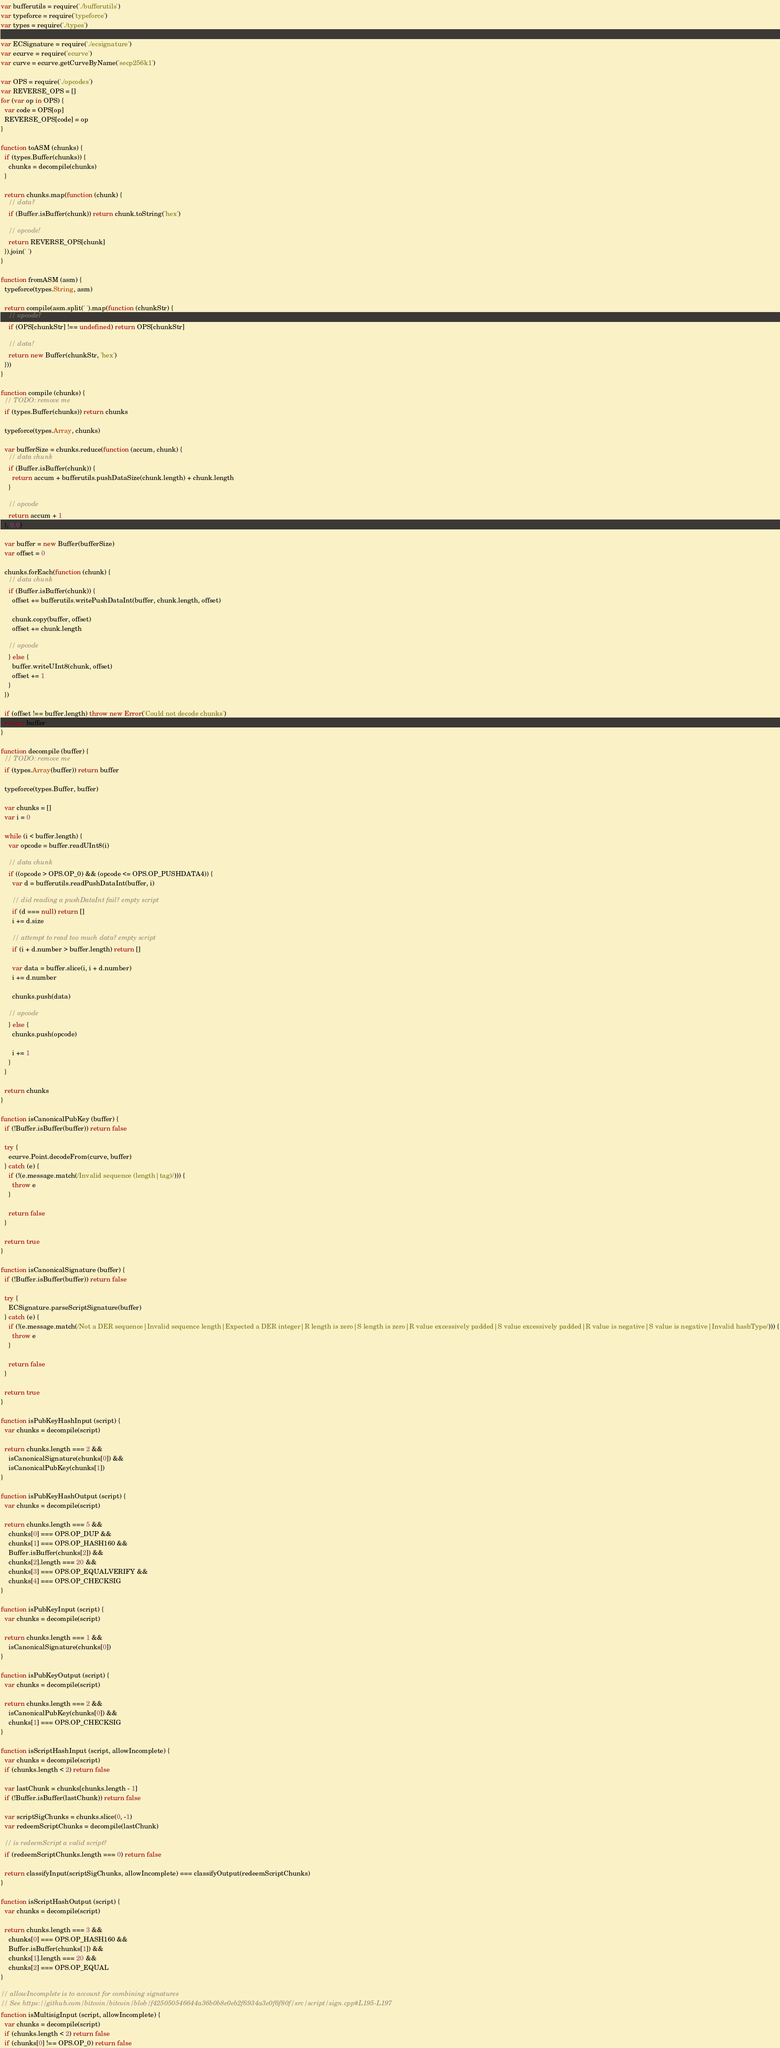Convert code to text. <code><loc_0><loc_0><loc_500><loc_500><_JavaScript_>var bufferutils = require('./bufferutils')
var typeforce = require('typeforce')
var types = require('./types')

var ECSignature = require('./ecsignature')
var ecurve = require('ecurve')
var curve = ecurve.getCurveByName('secp256k1')

var OPS = require('./opcodes')
var REVERSE_OPS = []
for (var op in OPS) {
  var code = OPS[op]
  REVERSE_OPS[code] = op
}

function toASM (chunks) {
  if (types.Buffer(chunks)) {
    chunks = decompile(chunks)
  }

  return chunks.map(function (chunk) {
    // data?
    if (Buffer.isBuffer(chunk)) return chunk.toString('hex')

    // opcode!
    return REVERSE_OPS[chunk]
  }).join(' ')
}

function fromASM (asm) {
  typeforce(types.String, asm)

  return compile(asm.split(' ').map(function (chunkStr) {
    // opcode?
    if (OPS[chunkStr] !== undefined) return OPS[chunkStr]

    // data!
    return new Buffer(chunkStr, 'hex')
  }))
}

function compile (chunks) {
  // TODO: remove me
  if (types.Buffer(chunks)) return chunks

  typeforce(types.Array, chunks)

  var bufferSize = chunks.reduce(function (accum, chunk) {
    // data chunk
    if (Buffer.isBuffer(chunk)) {
      return accum + bufferutils.pushDataSize(chunk.length) + chunk.length
    }

    // opcode
    return accum + 1
  }, 0.0)

  var buffer = new Buffer(bufferSize)
  var offset = 0

  chunks.forEach(function (chunk) {
    // data chunk
    if (Buffer.isBuffer(chunk)) {
      offset += bufferutils.writePushDataInt(buffer, chunk.length, offset)

      chunk.copy(buffer, offset)
      offset += chunk.length

    // opcode
    } else {
      buffer.writeUInt8(chunk, offset)
      offset += 1
    }
  })

  if (offset !== buffer.length) throw new Error('Could not decode chunks')
  return buffer
}

function decompile (buffer) {
  // TODO: remove me
  if (types.Array(buffer)) return buffer

  typeforce(types.Buffer, buffer)

  var chunks = []
  var i = 0

  while (i < buffer.length) {
    var opcode = buffer.readUInt8(i)

    // data chunk
    if ((opcode > OPS.OP_0) && (opcode <= OPS.OP_PUSHDATA4)) {
      var d = bufferutils.readPushDataInt(buffer, i)

      // did reading a pushDataInt fail? empty script
      if (d === null) return []
      i += d.size

      // attempt to read too much data? empty script
      if (i + d.number > buffer.length) return []

      var data = buffer.slice(i, i + d.number)
      i += d.number

      chunks.push(data)

    // opcode
    } else {
      chunks.push(opcode)

      i += 1
    }
  }

  return chunks
}

function isCanonicalPubKey (buffer) {
  if (!Buffer.isBuffer(buffer)) return false

  try {
    ecurve.Point.decodeFrom(curve, buffer)
  } catch (e) {
    if (!(e.message.match(/Invalid sequence (length|tag)/))) {
      throw e
    }

    return false
  }

  return true
}

function isCanonicalSignature (buffer) {
  if (!Buffer.isBuffer(buffer)) return false

  try {
    ECSignature.parseScriptSignature(buffer)
  } catch (e) {
    if (!(e.message.match(/Not a DER sequence|Invalid sequence length|Expected a DER integer|R length is zero|S length is zero|R value excessively padded|S value excessively padded|R value is negative|S value is negative|Invalid hashType/))) {
      throw e
    }

    return false
  }

  return true
}

function isPubKeyHashInput (script) {
  var chunks = decompile(script)

  return chunks.length === 2 &&
    isCanonicalSignature(chunks[0]) &&
    isCanonicalPubKey(chunks[1])
}

function isPubKeyHashOutput (script) {
  var chunks = decompile(script)

  return chunks.length === 5 &&
    chunks[0] === OPS.OP_DUP &&
    chunks[1] === OPS.OP_HASH160 &&
    Buffer.isBuffer(chunks[2]) &&
    chunks[2].length === 20 &&
    chunks[3] === OPS.OP_EQUALVERIFY &&
    chunks[4] === OPS.OP_CHECKSIG
}

function isPubKeyInput (script) {
  var chunks = decompile(script)

  return chunks.length === 1 &&
    isCanonicalSignature(chunks[0])
}

function isPubKeyOutput (script) {
  var chunks = decompile(script)

  return chunks.length === 2 &&
    isCanonicalPubKey(chunks[0]) &&
    chunks[1] === OPS.OP_CHECKSIG
}

function isScriptHashInput (script, allowIncomplete) {
  var chunks = decompile(script)
  if (chunks.length < 2) return false

  var lastChunk = chunks[chunks.length - 1]
  if (!Buffer.isBuffer(lastChunk)) return false

  var scriptSigChunks = chunks.slice(0, -1)
  var redeemScriptChunks = decompile(lastChunk)

  // is redeemScript a valid script?
  if (redeemScriptChunks.length === 0) return false

  return classifyInput(scriptSigChunks, allowIncomplete) === classifyOutput(redeemScriptChunks)
}

function isScriptHashOutput (script) {
  var chunks = decompile(script)

  return chunks.length === 3 &&
    chunks[0] === OPS.OP_HASH160 &&
    Buffer.isBuffer(chunks[1]) &&
    chunks[1].length === 20 &&
    chunks[2] === OPS.OP_EQUAL
}

// allowIncomplete is to account for combining signatures
// See https://github.com/bitcoin/bitcoin/blob/f425050546644a36b0b8e0eb2f6934a3e0f6f80f/src/script/sign.cpp#L195-L197
function isMultisigInput (script, allowIncomplete) {
  var chunks = decompile(script)
  if (chunks.length < 2) return false
  if (chunks[0] !== OPS.OP_0) return false
</code> 